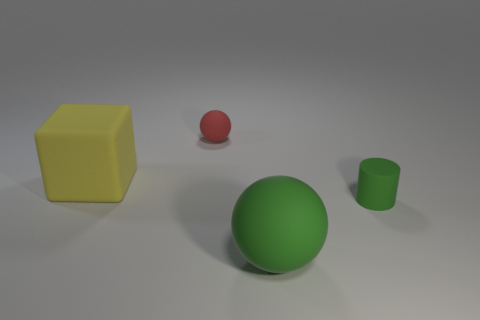Subtract all red spheres. How many spheres are left? 1 Subtract all blocks. How many objects are left? 3 Add 3 red matte balls. How many objects exist? 7 Subtract 2 balls. How many balls are left? 0 Add 4 green objects. How many green objects exist? 6 Subtract 0 green cubes. How many objects are left? 4 Subtract all gray spheres. Subtract all gray blocks. How many spheres are left? 2 Subtract all tiny matte spheres. Subtract all large green rubber objects. How many objects are left? 2 Add 4 small balls. How many small balls are left? 5 